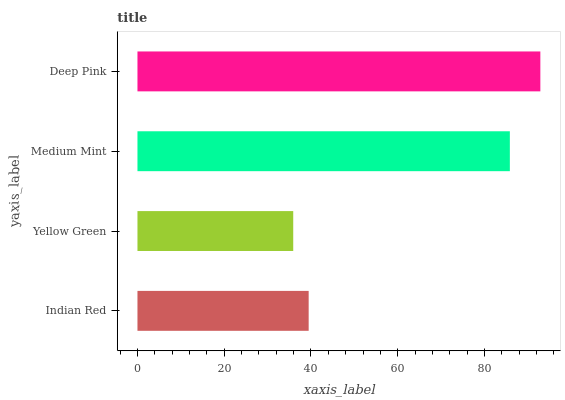Is Yellow Green the minimum?
Answer yes or no. Yes. Is Deep Pink the maximum?
Answer yes or no. Yes. Is Medium Mint the minimum?
Answer yes or no. No. Is Medium Mint the maximum?
Answer yes or no. No. Is Medium Mint greater than Yellow Green?
Answer yes or no. Yes. Is Yellow Green less than Medium Mint?
Answer yes or no. Yes. Is Yellow Green greater than Medium Mint?
Answer yes or no. No. Is Medium Mint less than Yellow Green?
Answer yes or no. No. Is Medium Mint the high median?
Answer yes or no. Yes. Is Indian Red the low median?
Answer yes or no. Yes. Is Indian Red the high median?
Answer yes or no. No. Is Yellow Green the low median?
Answer yes or no. No. 